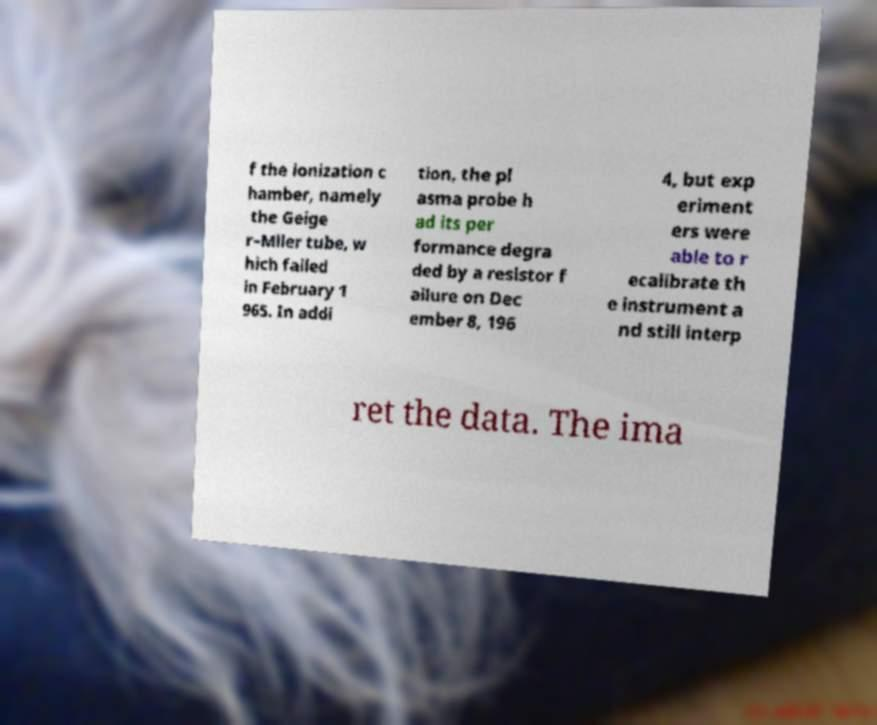Please identify and transcribe the text found in this image. f the ionization c hamber, namely the Geige r–Mller tube, w hich failed in February 1 965. In addi tion, the pl asma probe h ad its per formance degra ded by a resistor f ailure on Dec ember 8, 196 4, but exp eriment ers were able to r ecalibrate th e instrument a nd still interp ret the data. The ima 